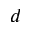Convert formula to latex. <formula><loc_0><loc_0><loc_500><loc_500>d</formula> 